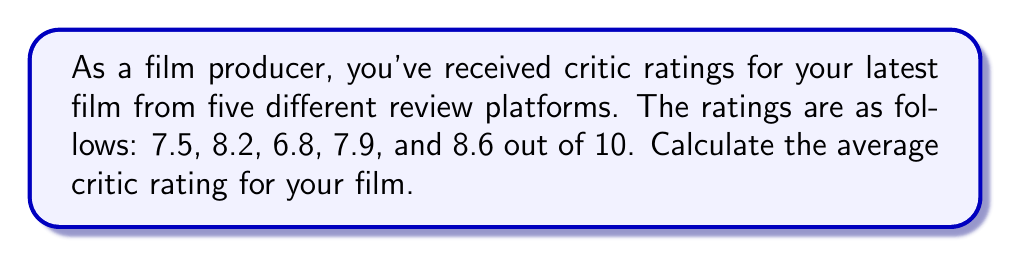Can you answer this question? To calculate the average critic rating, we need to follow these steps:

1. Sum up all the ratings:
   $7.5 + 8.2 + 6.8 + 7.9 + 8.6 = 39$

2. Count the total number of ratings:
   There are 5 ratings in total.

3. Divide the sum by the total number of ratings:
   $$\text{Average} = \frac{\text{Sum of ratings}}{\text{Number of ratings}}$$
   $$\text{Average} = \frac{39}{5} = 7.8$$

Therefore, the average critic rating for your film is 7.8 out of 10.
Answer: 7.8 